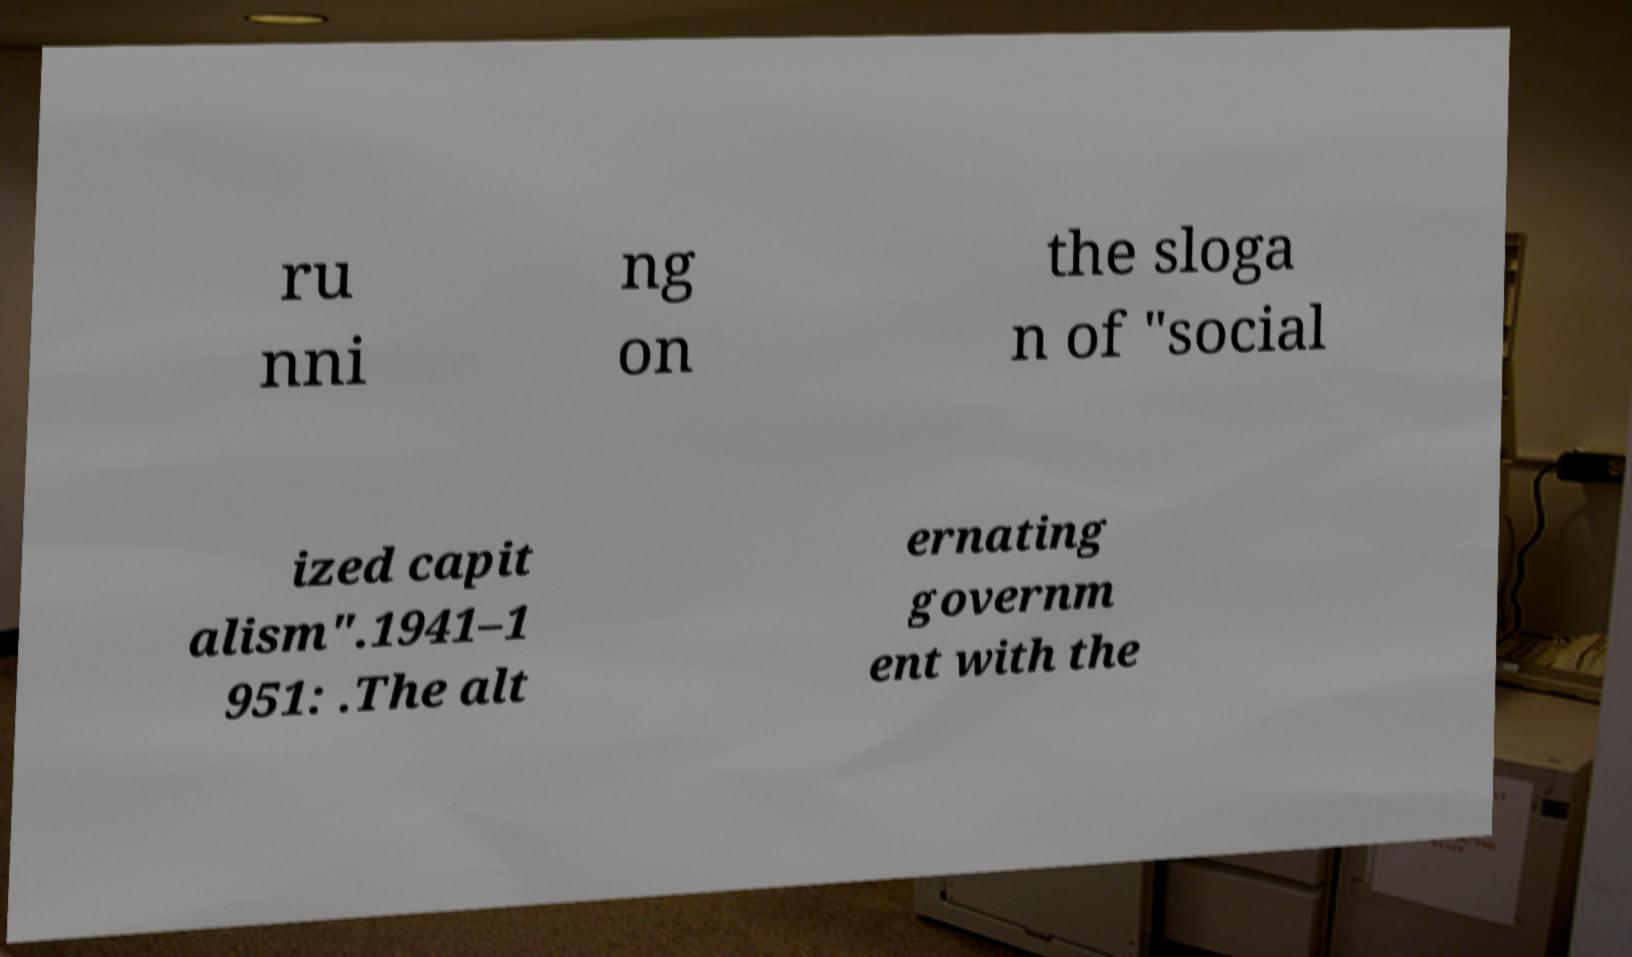What messages or text are displayed in this image? I need them in a readable, typed format. ru nni ng on the sloga n of "social ized capit alism".1941–1 951: .The alt ernating governm ent with the 